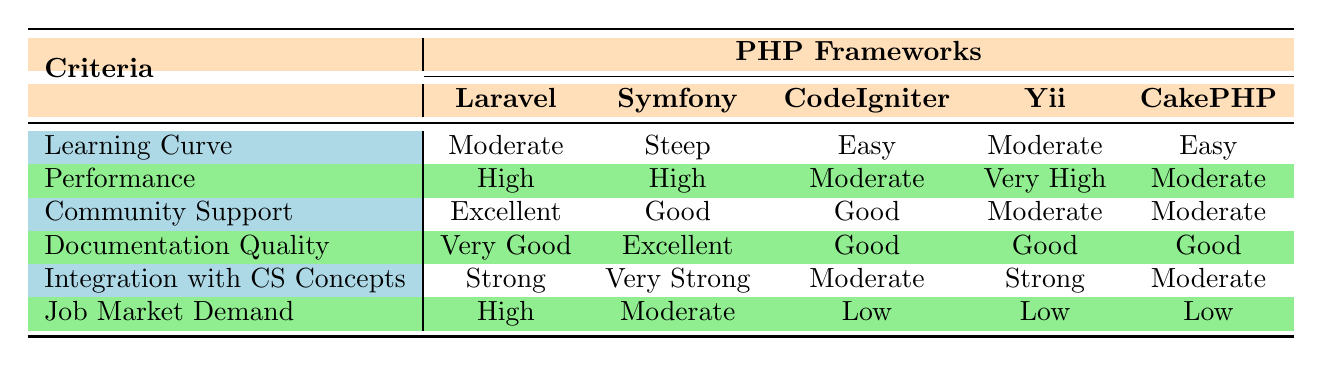What is the learning curve for Laravel? The table indicates the learning curve for Laravel is listed as "Moderate".
Answer: Moderate Which framework has the highest performance rating? From the table, "Yii" has the performance rating of "Very High", which is higher than any other framework listed.
Answer: Very High Is the community support for CodeIgniter good? The table states that the community support for CodeIgniter is marked as "Good", which confirms the statement.
Answer: Yes Which frameworks have low job market demand? The table shows that CodeIgniter, Yii, and CakePHP all have "Low" for job market demand, meaning they fall under this category.
Answer: CodeIgniter, Yii, CakePHP What is the difference in documentation quality between Symfony and CakePHP? According to the table, Symfony has "Excellent" documentation quality while CakePHP has "Good". The difference is that Symfony has a higher rating by one level.
Answer: One level Which framework is the best choice considering both community support and job market demand? Analyzing the table, Laravel stands out with "Excellent" community support and "High" job market demand, making it the best choice overall based on these criteria.
Answer: Laravel How many frameworks have a "Moderate" performance rating? The table shows that only CodeIgniter and CakePHP have a "Moderate" performance rating. Therefore, there are two frameworks fitting this description.
Answer: Two frameworks Is there a framework with an easy learning curve that has high performance? The table indicates that while both CodeIgniter and CakePHP have an easy learning curve, their performance ratings are moderate. None of the frameworks with easy learning curves have high performance.
Answer: No Which framework has a strong integration with computer science concepts but low job market demand? From the table, Yii fits this requirement as it has a "Strong" integration with computer science concepts but is rated "Low" for job market demand.
Answer: Yii 